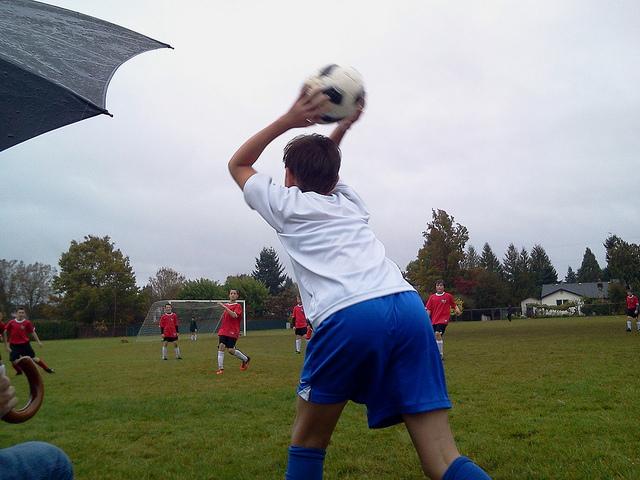What game are these people playing?
Keep it brief. Soccer. What sport are they playing?
Short answer required. Soccer. What color are the shorts of the boy with the ball?
Concise answer only. Blue. Is this boy playing football?
Write a very short answer. Yes. What is being thrown?
Be succinct. Soccer ball. What sport are the boys playing?
Quick response, please. Soccer. 